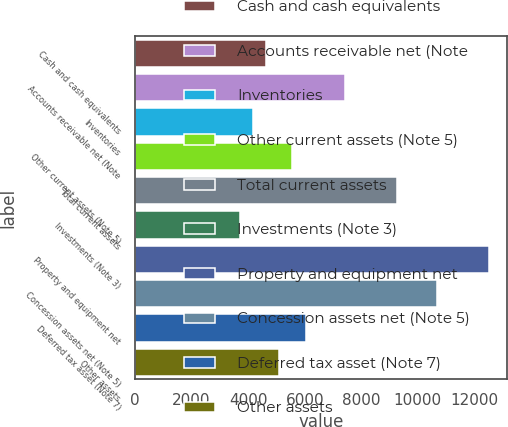Convert chart. <chart><loc_0><loc_0><loc_500><loc_500><bar_chart><fcel>Cash and cash equivalents<fcel>Accounts receivable net (Note<fcel>Inventories<fcel>Other current assets (Note 5)<fcel>Total current assets<fcel>Investments (Note 3)<fcel>Property and equipment net<fcel>Concession assets net (Note 5)<fcel>Deferred tax asset (Note 7)<fcel>Other assets<nl><fcel>4637.3<fcel>7419.56<fcel>4173.59<fcel>5564.72<fcel>9274.4<fcel>3709.88<fcel>12520.4<fcel>10665.5<fcel>6028.43<fcel>5101.01<nl></chart> 